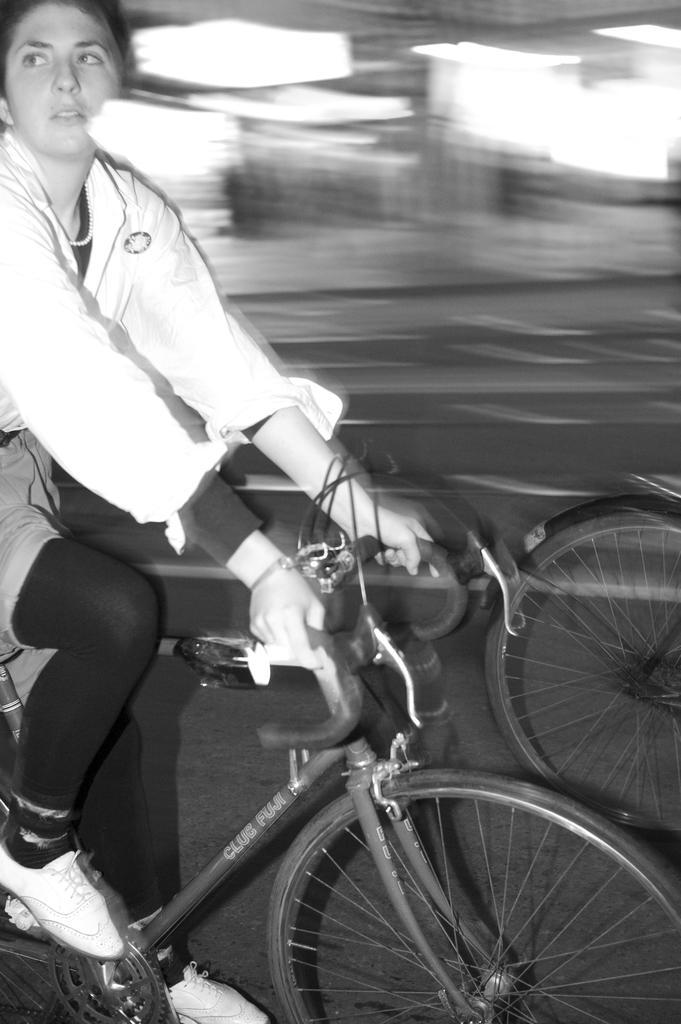How would you summarize this image in a sentence or two? In this picture there is a woman riding a bicycle, she held the bicycle handle with both of the hands and there is another bicycle in front of her, she is staring at something else and in the background there is a road. 